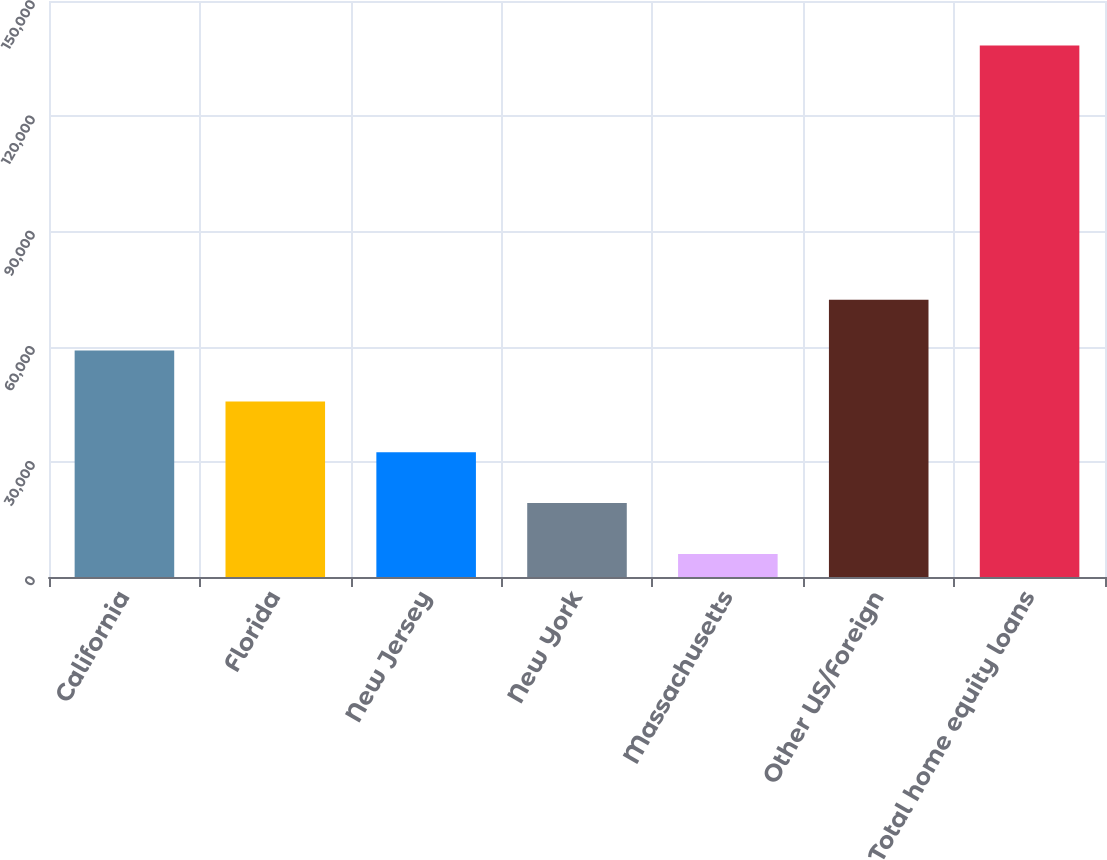Convert chart to OTSL. <chart><loc_0><loc_0><loc_500><loc_500><bar_chart><fcel>California<fcel>Florida<fcel>New Jersey<fcel>New York<fcel>Massachusetts<fcel>Other US/Foreign<fcel>Total home equity loans<nl><fcel>58958.4<fcel>45720.8<fcel>32483.2<fcel>19245.6<fcel>6008<fcel>72196<fcel>138384<nl></chart> 